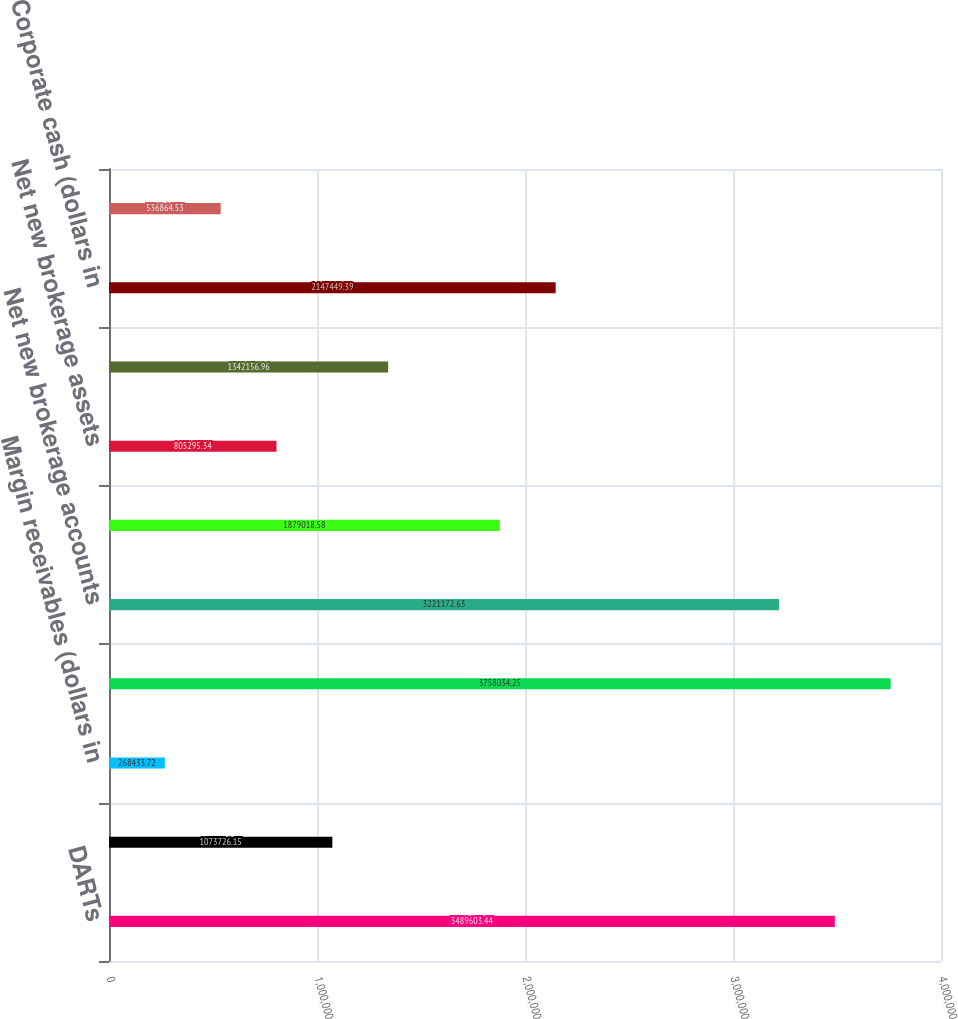Convert chart to OTSL. <chart><loc_0><loc_0><loc_500><loc_500><bar_chart><fcel>DARTs<fcel>Average commission per trade<fcel>Margin receivables (dollars in<fcel>End of period brokerage<fcel>Net new brokerage accounts<fcel>Customer assets (dollars in<fcel>Net new brokerage assets<fcel>Brokerage related cash<fcel>Corporate cash (dollars in<fcel>ETRADE Bank Tier 1 leverage<nl><fcel>3.4896e+06<fcel>1.07373e+06<fcel>268434<fcel>3.75803e+06<fcel>3.22117e+06<fcel>1.87902e+06<fcel>805295<fcel>1.34216e+06<fcel>2.14745e+06<fcel>536865<nl></chart> 